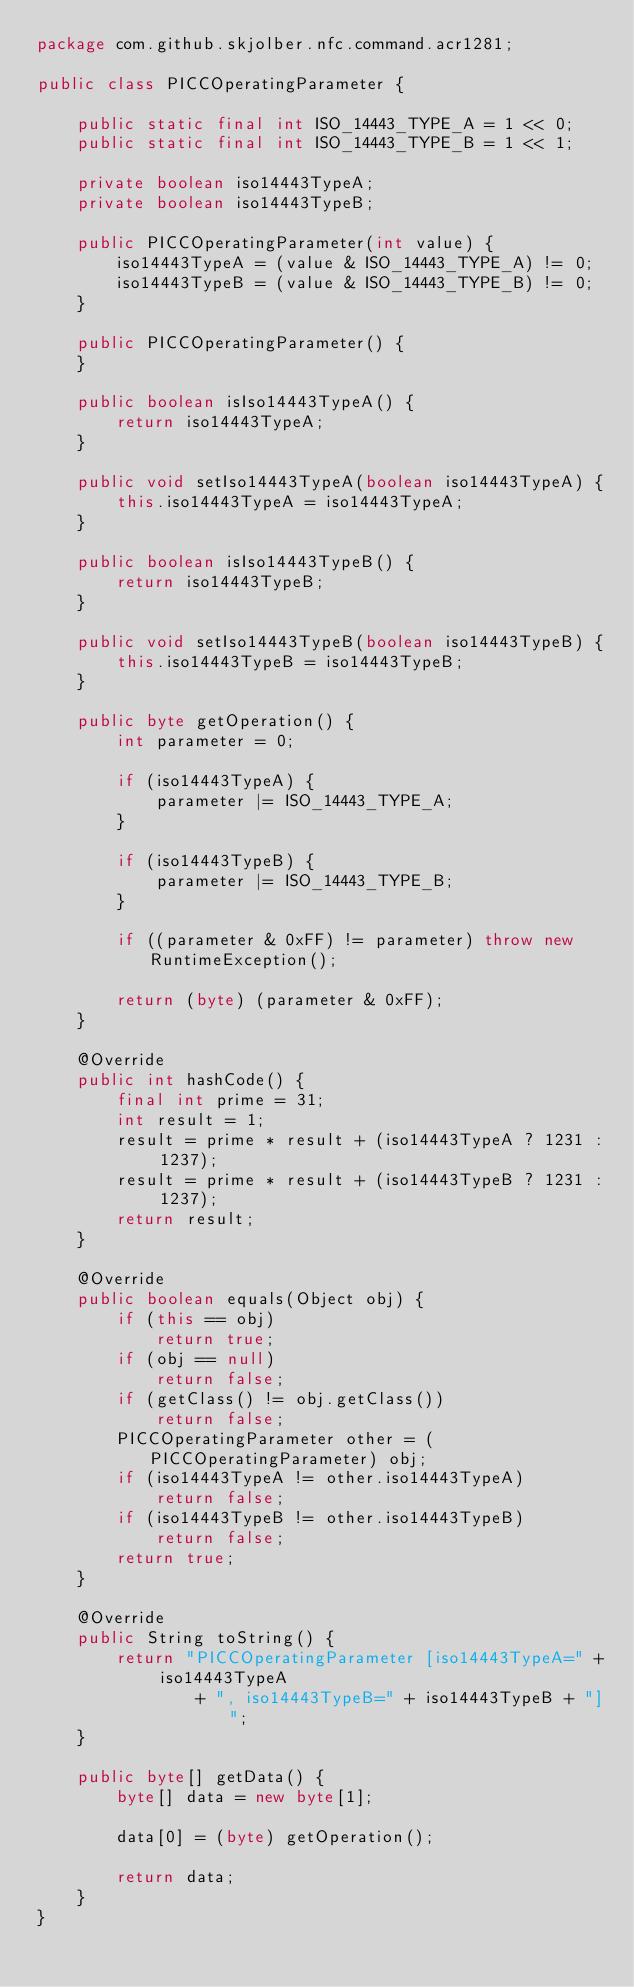<code> <loc_0><loc_0><loc_500><loc_500><_Java_>package com.github.skjolber.nfc.command.acr1281;

public class PICCOperatingParameter {

    public static final int ISO_14443_TYPE_A = 1 << 0;
    public static final int ISO_14443_TYPE_B = 1 << 1;

    private boolean iso14443TypeA;
    private boolean iso14443TypeB;

    public PICCOperatingParameter(int value) {
        iso14443TypeA = (value & ISO_14443_TYPE_A) != 0;
        iso14443TypeB = (value & ISO_14443_TYPE_B) != 0;
    }

    public PICCOperatingParameter() {
    }

    public boolean isIso14443TypeA() {
        return iso14443TypeA;
    }

    public void setIso14443TypeA(boolean iso14443TypeA) {
        this.iso14443TypeA = iso14443TypeA;
    }

    public boolean isIso14443TypeB() {
        return iso14443TypeB;
    }

    public void setIso14443TypeB(boolean iso14443TypeB) {
        this.iso14443TypeB = iso14443TypeB;
    }

    public byte getOperation() {
        int parameter = 0;

        if (iso14443TypeA) {
            parameter |= ISO_14443_TYPE_A;
        }

        if (iso14443TypeB) {
            parameter |= ISO_14443_TYPE_B;
        }

        if ((parameter & 0xFF) != parameter) throw new RuntimeException();

        return (byte) (parameter & 0xFF);
    }

    @Override
    public int hashCode() {
        final int prime = 31;
        int result = 1;
        result = prime * result + (iso14443TypeA ? 1231 : 1237);
        result = prime * result + (iso14443TypeB ? 1231 : 1237);
        return result;
    }

    @Override
    public boolean equals(Object obj) {
        if (this == obj)
            return true;
        if (obj == null)
            return false;
        if (getClass() != obj.getClass())
            return false;
        PICCOperatingParameter other = (PICCOperatingParameter) obj;
        if (iso14443TypeA != other.iso14443TypeA)
            return false;
        if (iso14443TypeB != other.iso14443TypeB)
            return false;
        return true;
    }

    @Override
    public String toString() {
        return "PICCOperatingParameter [iso14443TypeA=" + iso14443TypeA
                + ", iso14443TypeB=" + iso14443TypeB + "]";
    }

    public byte[] getData() {
        byte[] data = new byte[1];

        data[0] = (byte) getOperation();

        return data;
    }
}
</code> 